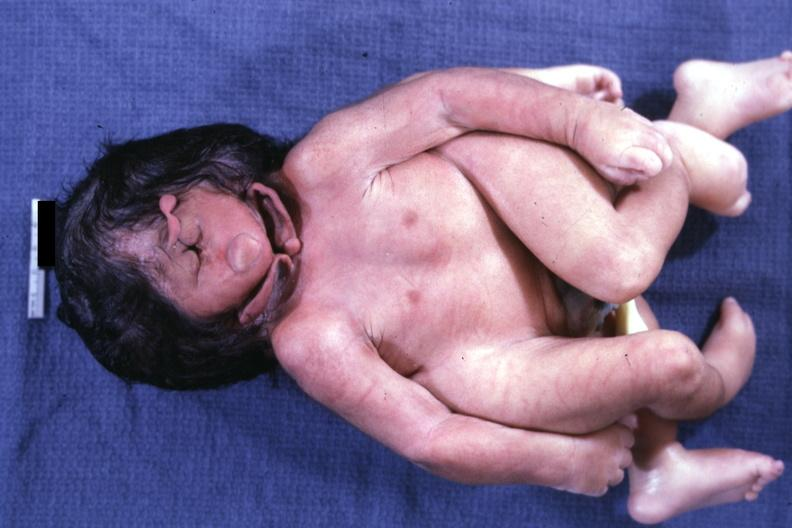what does this image show?
Answer the question using a single word or phrase. Anterior lateral view of monster 